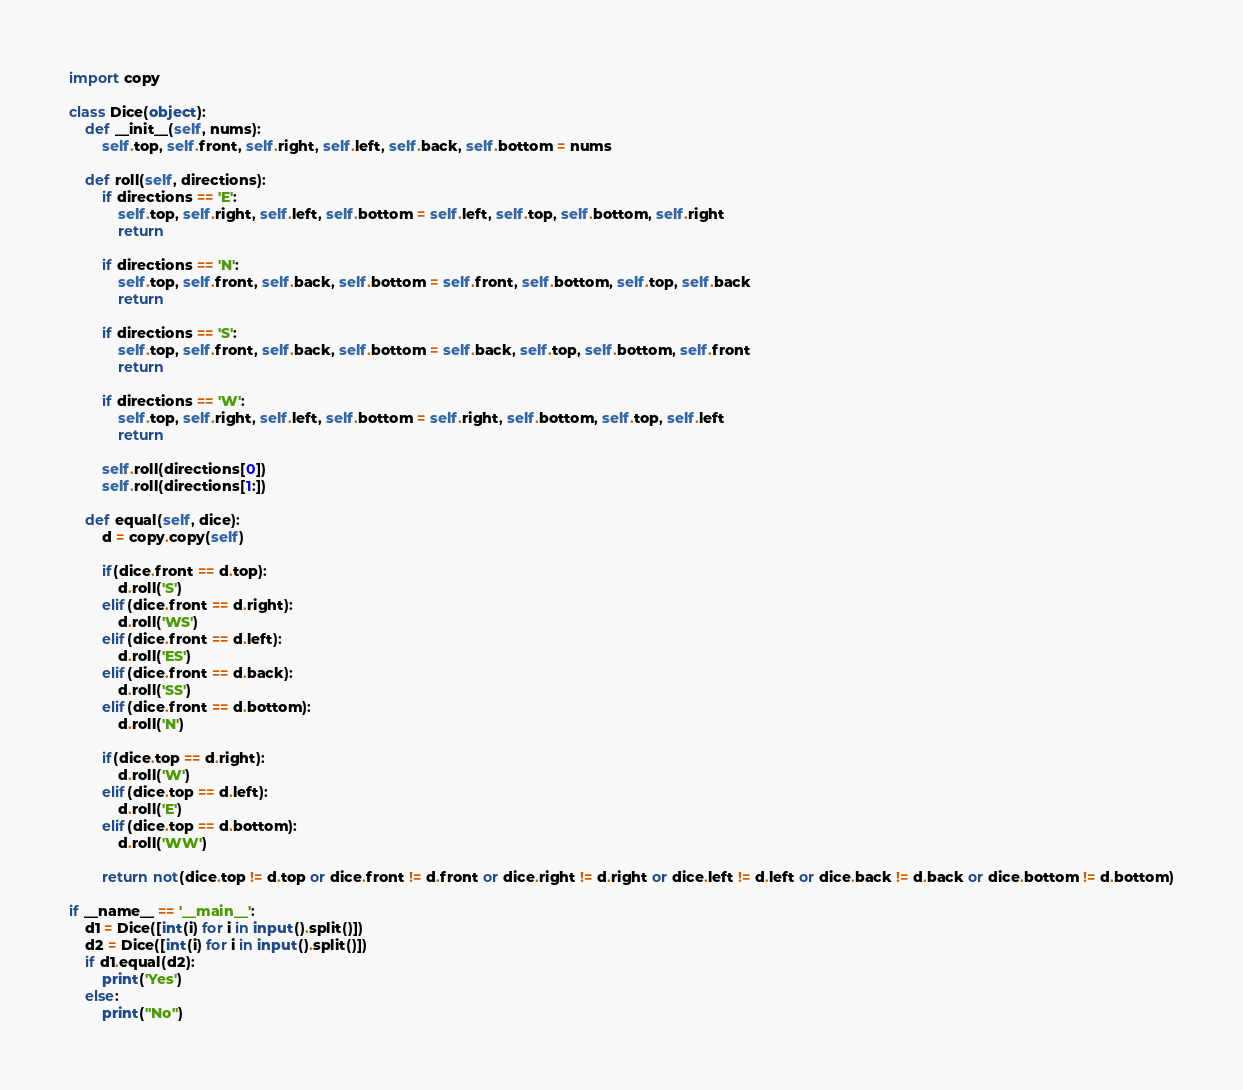Convert code to text. <code><loc_0><loc_0><loc_500><loc_500><_Python_>import copy

class Dice(object):
    def __init__(self, nums):
        self.top, self.front, self.right, self.left, self.back, self.bottom = nums

    def roll(self, directions):
        if directions == 'E':
            self.top, self.right, self.left, self.bottom = self.left, self.top, self.bottom, self.right
            return

        if directions == 'N':
            self.top, self.front, self.back, self.bottom = self.front, self.bottom, self.top, self.back
            return

        if directions == 'S':
            self.top, self.front, self.back, self.bottom = self.back, self.top, self.bottom, self.front
            return

        if directions == 'W':
            self.top, self.right, self.left, self.bottom = self.right, self.bottom, self.top, self.left
            return

        self.roll(directions[0])
        self.roll(directions[1:])

    def equal(self, dice):
        d = copy.copy(self)

        if(dice.front == d.top):
            d.roll('S')
        elif(dice.front == d.right):
            d.roll('WS')
        elif(dice.front == d.left):
            d.roll('ES')
        elif(dice.front == d.back):
            d.roll('SS')
        elif(dice.front == d.bottom):
            d.roll('N')

        if(dice.top == d.right):
            d.roll('W')
        elif(dice.top == d.left):
            d.roll('E')
        elif(dice.top == d.bottom):
            d.roll('WW')

        return not(dice.top != d.top or dice.front != d.front or dice.right != d.right or dice.left != d.left or dice.back != d.back or dice.bottom != d.bottom)

if __name__ == '__main__':
    d1 = Dice([int(i) for i in input().split()])
    d2 = Dice([int(i) for i in input().split()])
    if d1.equal(d2):
        print('Yes')
    else:
        print("No")</code> 